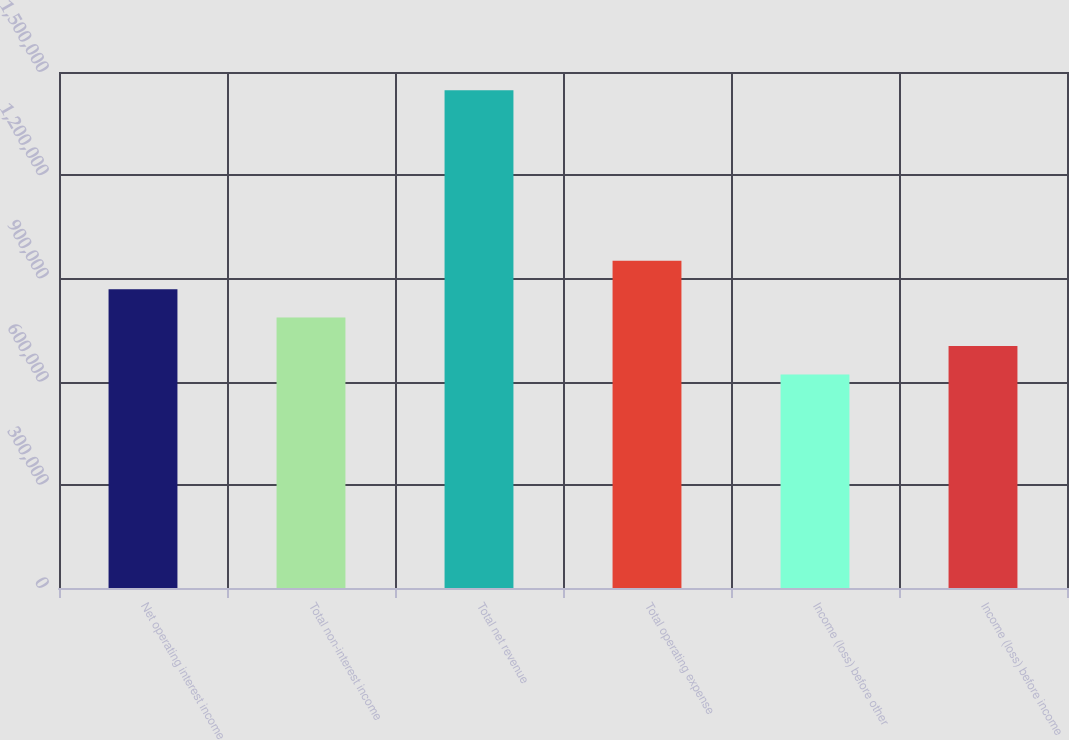<chart> <loc_0><loc_0><loc_500><loc_500><bar_chart><fcel>Net operating interest income<fcel>Total non-interest income<fcel>Total net revenue<fcel>Total operating expense<fcel>Income (loss) before other<fcel>Income (loss) before income<nl><fcel>868734<fcel>786140<fcel>1.44689e+06<fcel>951328<fcel>620952<fcel>703546<nl></chart> 